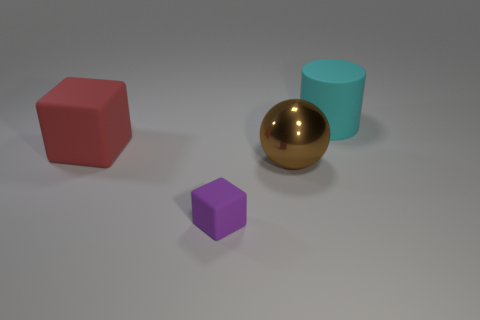Are there any tiny blue matte objects of the same shape as the big red rubber object?
Make the answer very short. No. There is a rubber object to the left of the small purple matte block; what size is it?
Make the answer very short. Large. There is a cyan thing that is the same size as the red matte cube; what material is it?
Your response must be concise. Rubber. Are there more tiny purple matte objects than rubber things?
Provide a short and direct response. No. What size is the rubber object that is behind the big matte thing on the left side of the tiny object?
Make the answer very short. Large. The other rubber thing that is the same size as the cyan rubber thing is what shape?
Give a very brief answer. Cube. What shape is the brown thing that is to the right of the block that is in front of the big rubber thing that is in front of the big cyan rubber thing?
Give a very brief answer. Sphere. Does the matte object that is right of the brown ball have the same color as the cube that is on the left side of the purple cube?
Provide a succinct answer. No. What number of large red metallic objects are there?
Provide a succinct answer. 0. There is a red thing; are there any red matte blocks in front of it?
Make the answer very short. No. 